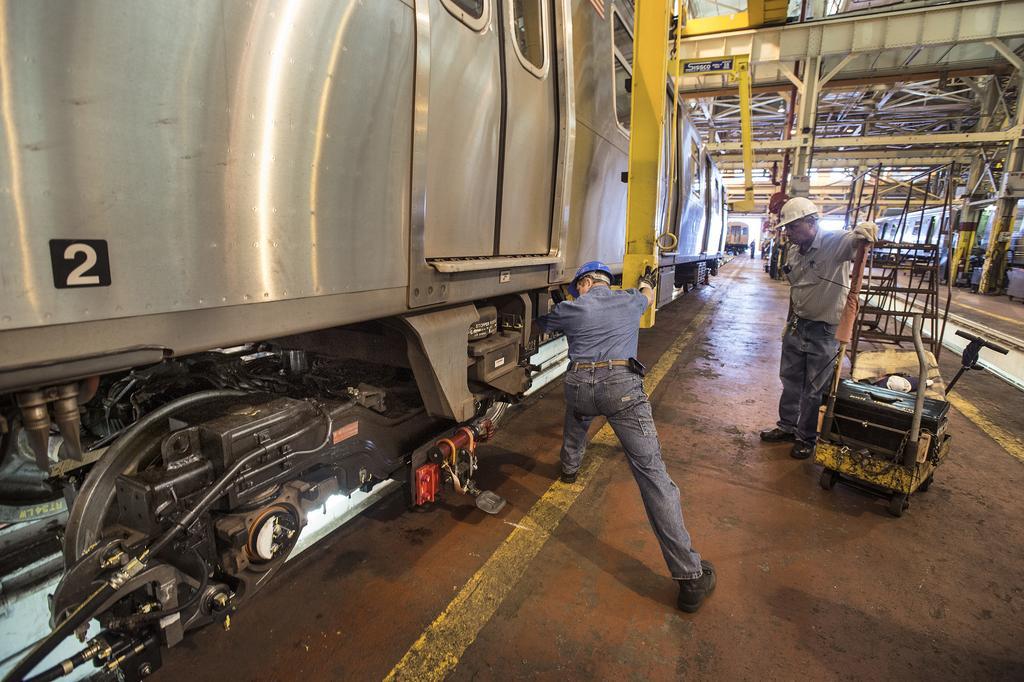Could you give a brief overview of what you see in this image? This is a train with doors and windows. I think this is an engine, which is attached to the train. There are two people standing. I think this is the locomotive shed, which is built with iron. 